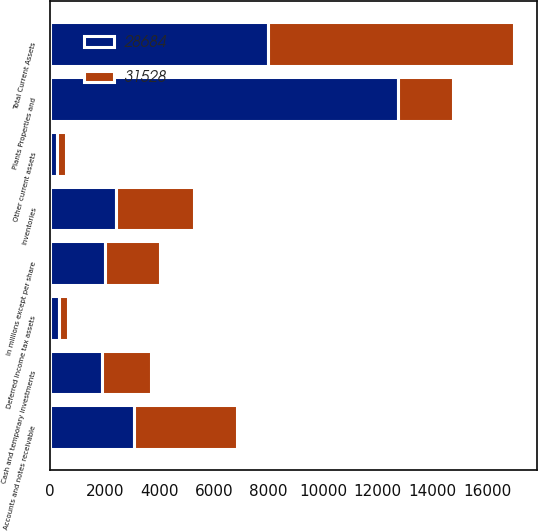Convert chart. <chart><loc_0><loc_0><loc_500><loc_500><stacked_bar_chart><ecel><fcel>In millions except per share<fcel>Cash and temporary investments<fcel>Accounts and notes receivable<fcel>Inventories<fcel>Deferred income tax assets<fcel>Other current assets<fcel>Total Current Assets<fcel>Plants Properties and<nl><fcel>28684<fcel>2014<fcel>1881<fcel>3083<fcel>2424<fcel>331<fcel>240<fcel>7959<fcel>12728<nl><fcel>31528<fcel>2013<fcel>1802<fcel>3756<fcel>2825<fcel>302<fcel>340<fcel>9025<fcel>2014<nl></chart> 